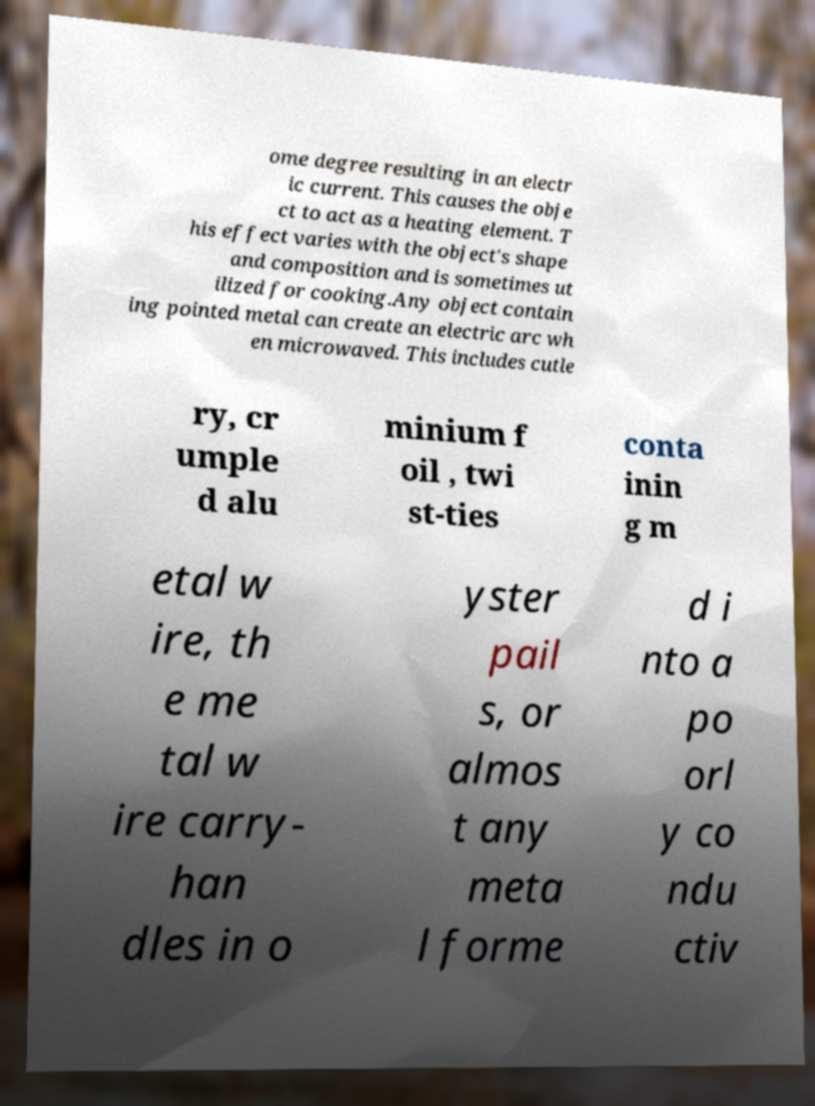Can you accurately transcribe the text from the provided image for me? ome degree resulting in an electr ic current. This causes the obje ct to act as a heating element. T his effect varies with the object's shape and composition and is sometimes ut ilized for cooking.Any object contain ing pointed metal can create an electric arc wh en microwaved. This includes cutle ry, cr umple d alu minium f oil , twi st-ties conta inin g m etal w ire, th e me tal w ire carry- han dles in o yster pail s, or almos t any meta l forme d i nto a po orl y co ndu ctiv 